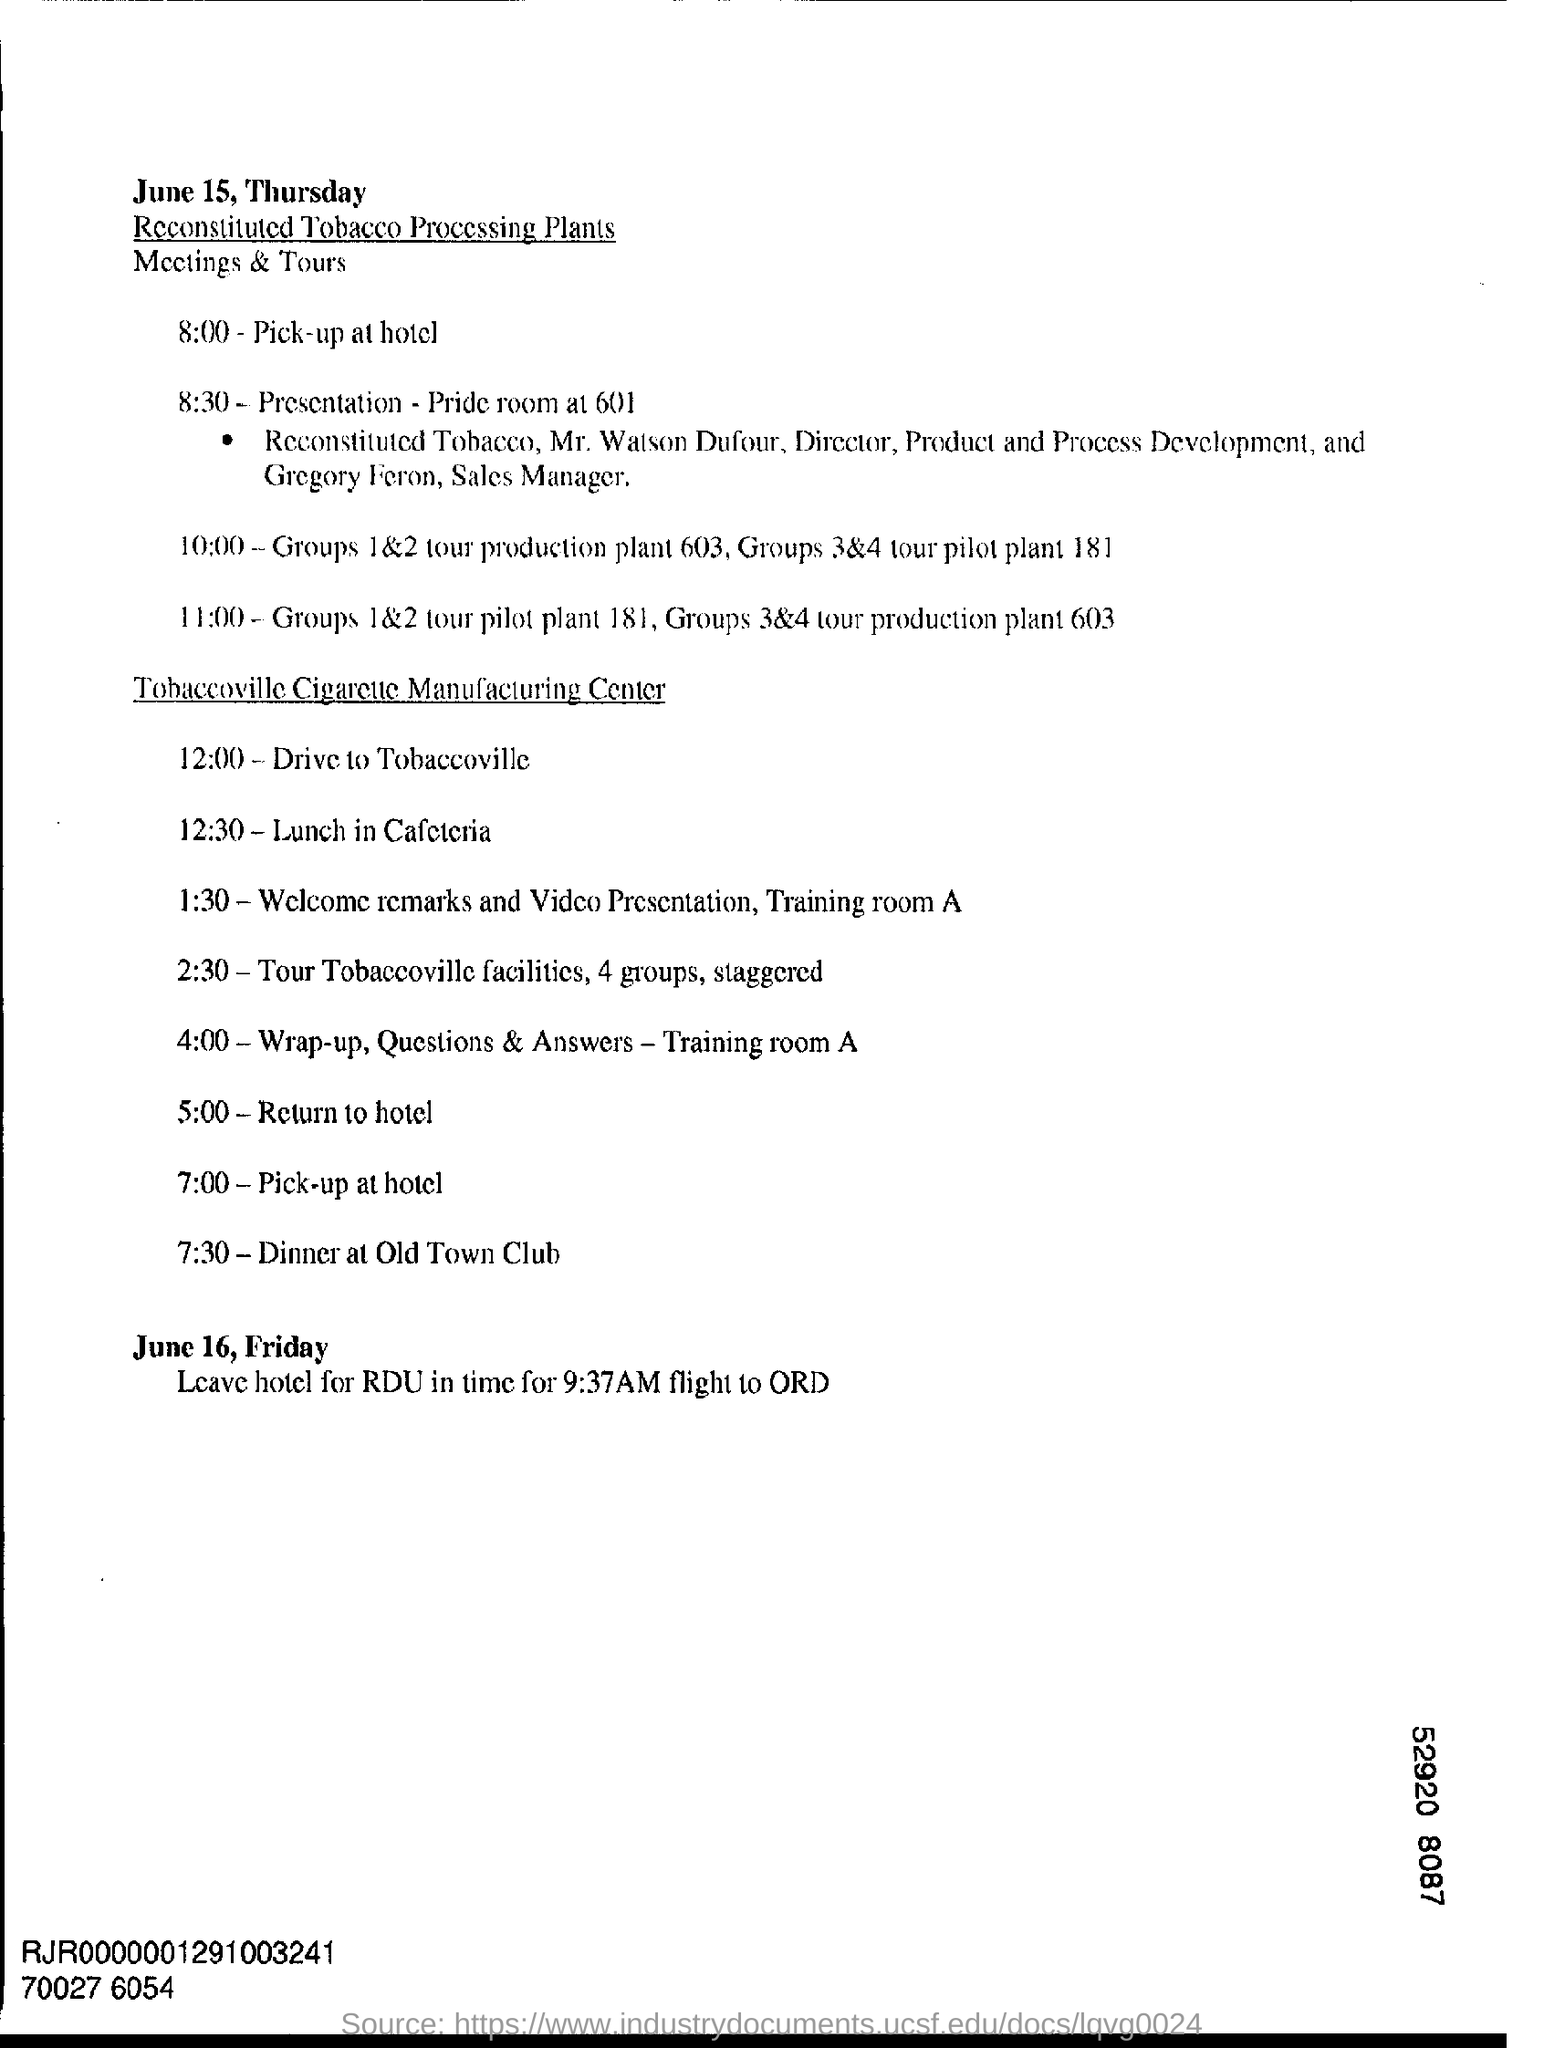What is the Timing of Pick-up at Hotel at manufacturing center ?
Your answer should be very brief. 7:00. What is the date mentioned in the top of the document ?
Offer a very short reply. June 15, Thursday. 